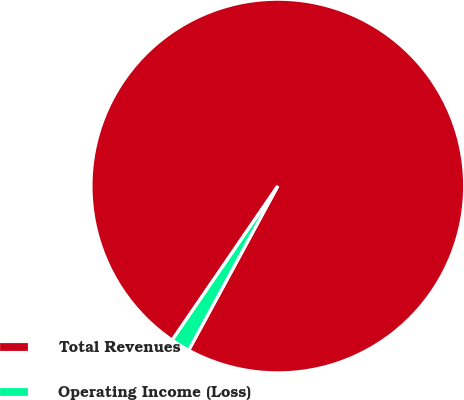Convert chart. <chart><loc_0><loc_0><loc_500><loc_500><pie_chart><fcel>Total Revenues<fcel>Operating Income (Loss)<nl><fcel>98.35%<fcel>1.65%<nl></chart> 